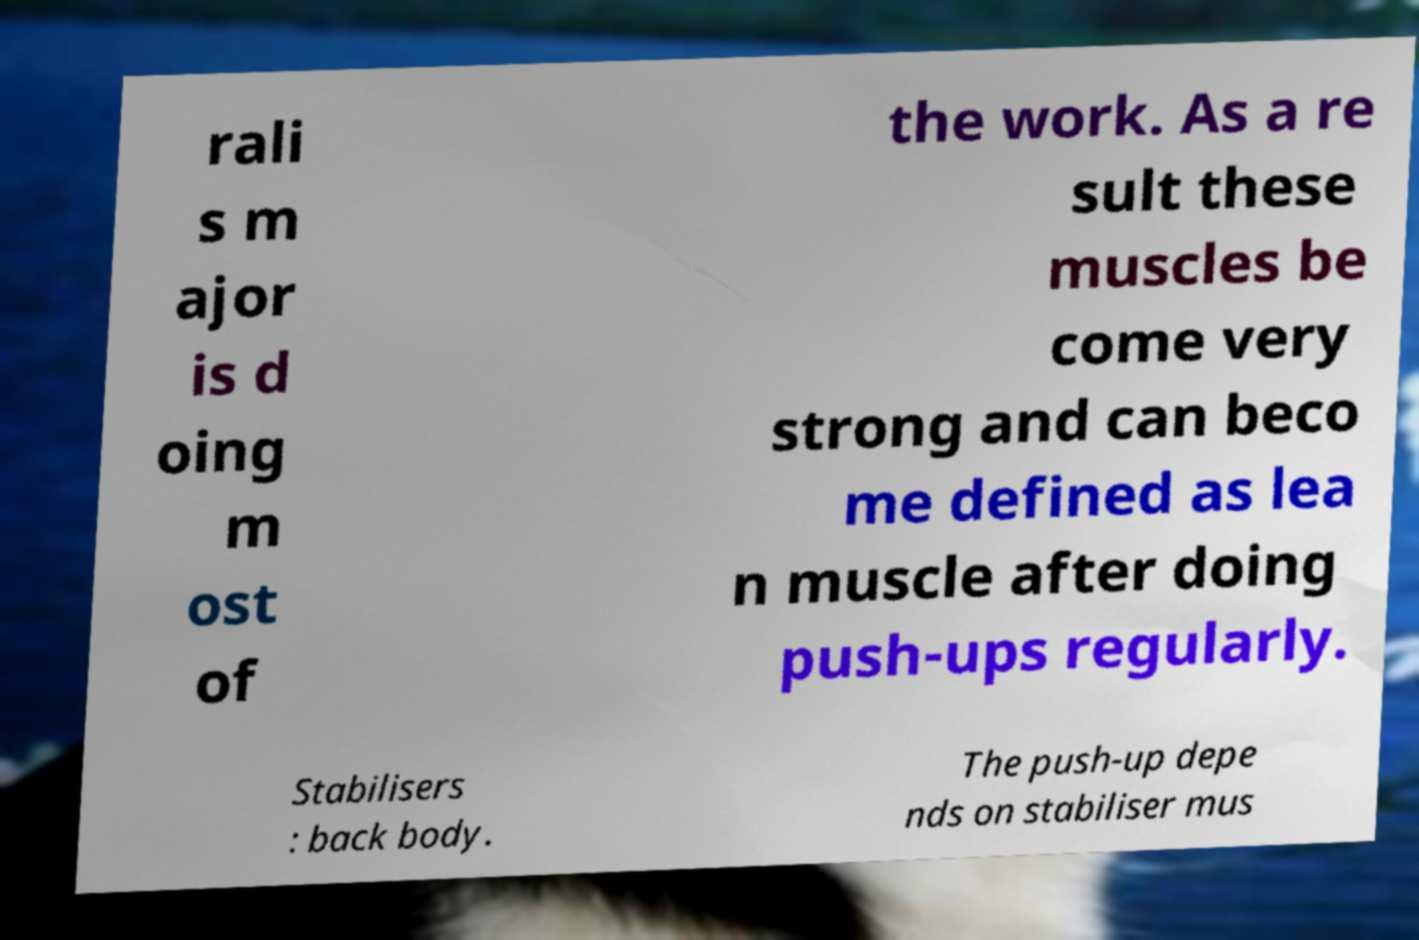I need the written content from this picture converted into text. Can you do that? rali s m ajor is d oing m ost of the work. As a re sult these muscles be come very strong and can beco me defined as lea n muscle after doing push-ups regularly. Stabilisers : back body. The push-up depe nds on stabiliser mus 